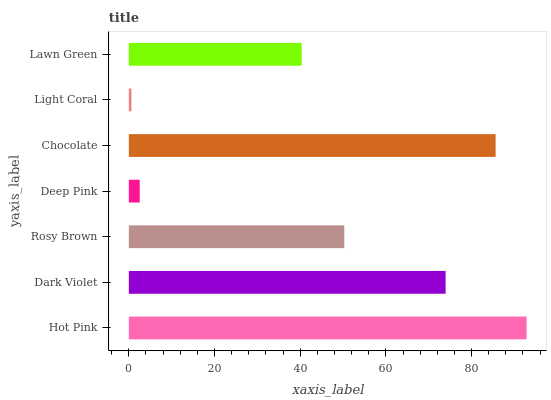Is Light Coral the minimum?
Answer yes or no. Yes. Is Hot Pink the maximum?
Answer yes or no. Yes. Is Dark Violet the minimum?
Answer yes or no. No. Is Dark Violet the maximum?
Answer yes or no. No. Is Hot Pink greater than Dark Violet?
Answer yes or no. Yes. Is Dark Violet less than Hot Pink?
Answer yes or no. Yes. Is Dark Violet greater than Hot Pink?
Answer yes or no. No. Is Hot Pink less than Dark Violet?
Answer yes or no. No. Is Rosy Brown the high median?
Answer yes or no. Yes. Is Rosy Brown the low median?
Answer yes or no. Yes. Is Lawn Green the high median?
Answer yes or no. No. Is Chocolate the low median?
Answer yes or no. No. 